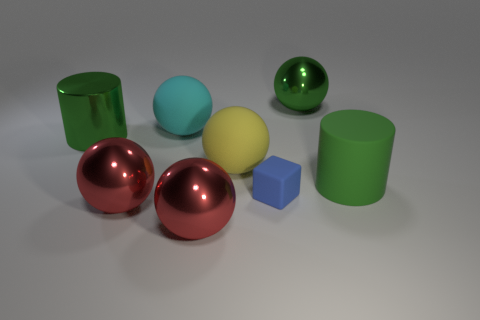Subtract all cyan spheres. How many spheres are left? 4 Subtract all big yellow balls. How many balls are left? 4 Subtract all gray balls. Subtract all red cylinders. How many balls are left? 5 Add 2 large yellow things. How many objects exist? 10 Subtract all cylinders. How many objects are left? 6 Subtract all small objects. Subtract all large green rubber cylinders. How many objects are left? 6 Add 5 spheres. How many spheres are left? 10 Add 6 large yellow objects. How many large yellow objects exist? 7 Subtract 0 brown balls. How many objects are left? 8 